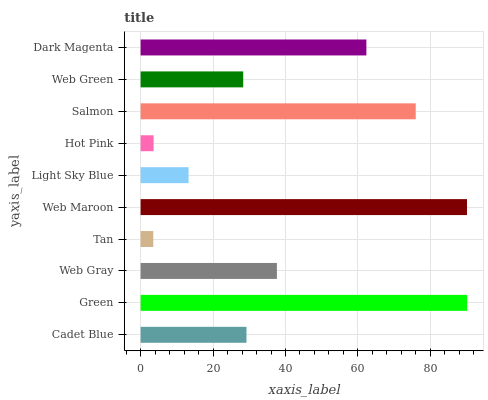Is Tan the minimum?
Answer yes or no. Yes. Is Green the maximum?
Answer yes or no. Yes. Is Web Gray the minimum?
Answer yes or no. No. Is Web Gray the maximum?
Answer yes or no. No. Is Green greater than Web Gray?
Answer yes or no. Yes. Is Web Gray less than Green?
Answer yes or no. Yes. Is Web Gray greater than Green?
Answer yes or no. No. Is Green less than Web Gray?
Answer yes or no. No. Is Web Gray the high median?
Answer yes or no. Yes. Is Cadet Blue the low median?
Answer yes or no. Yes. Is Tan the high median?
Answer yes or no. No. Is Web Gray the low median?
Answer yes or no. No. 